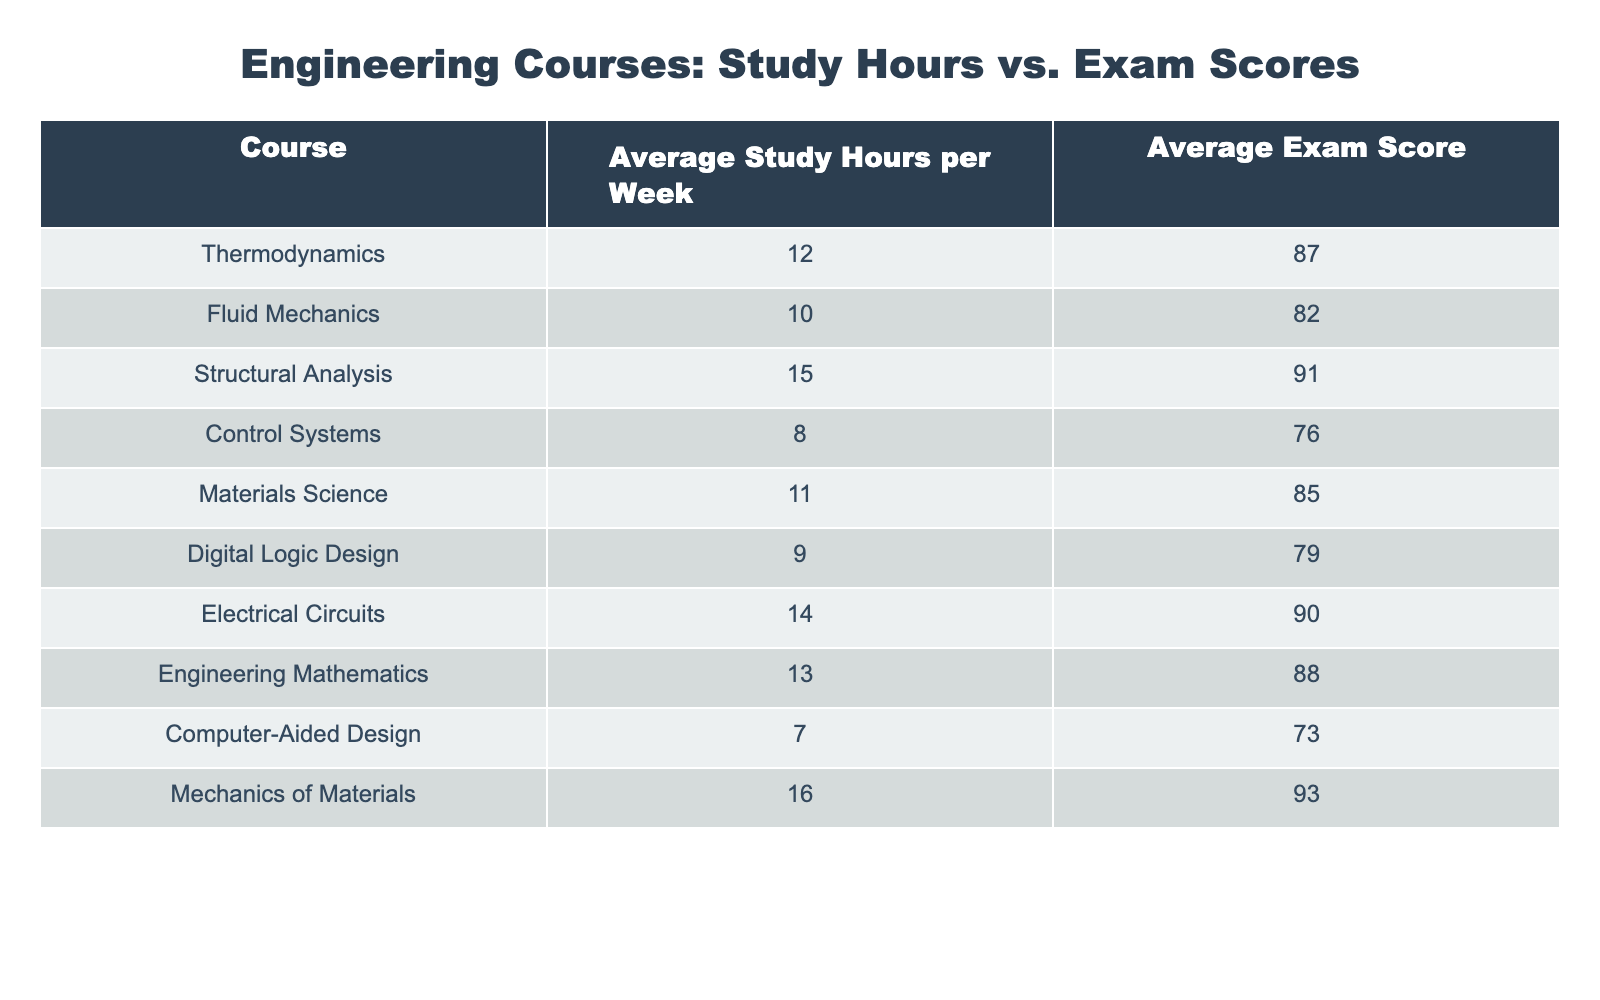What is the average exam score for Fluid Mechanics? The table indicates that the average exam score for Fluid Mechanics is directly listed as 82.
Answer: 82 How many average study hours does Structural Analysis require per week? According to the table, Structural Analysis requires an average of 15 study hours per week.
Answer: 15 Which course has the highest average exam score? By comparing the exam scores, Mechanics of Materials has the highest score at 93.
Answer: Mechanics of Materials What is the difference in average exam scores between Electrical Circuits and Control Systems? Electrical Circuits has an average score of 90, and Control Systems has 76. The difference is 90 - 76 = 14.
Answer: 14 What is the total number of average study hours for the courses listed? To find the total, sum the study hours: 12 + 10 + 15 + 8 + 11 + 9 + 14 + 13 + 7 + 16 = 125.
Answer: 125 Is the average score for Digital Logic Design greater than or equal to 80? The average exam score for Digital Logic Design is 79, which is less than 80.
Answer: No What is the average exam score for all courses? The average score can be calculated by summing all scores (87 + 82 + 91 + 76 + 85 + 79 + 90 + 88 + 73 + 93 = 885) then dividing by the number of courses (10) to get 885 / 10 = 88.5.
Answer: 88.5 Which courses have an average score above 85 and require more than 10 study hours? The courses that meet these criteria are Structural Analysis (91), Electrical Circuits (90), and Mechanics of Materials (93).
Answer: Structural Analysis, Electrical Circuits, Mechanics of Materials How many courses have an average study hour less than 10? By looking at the table, the courses with study hours less than 10 are Digital Logic Design (9) and Control Systems (8), making a total of 2 courses.
Answer: 2 What is the average number of study hours for the courses with exam scores below 80? The only course with an exam score below 80 is Digital Logic Design (9 hours) and Control Systems (8 hours). The average is (9 + 8) / 2 = 8.5.
Answer: 8.5 